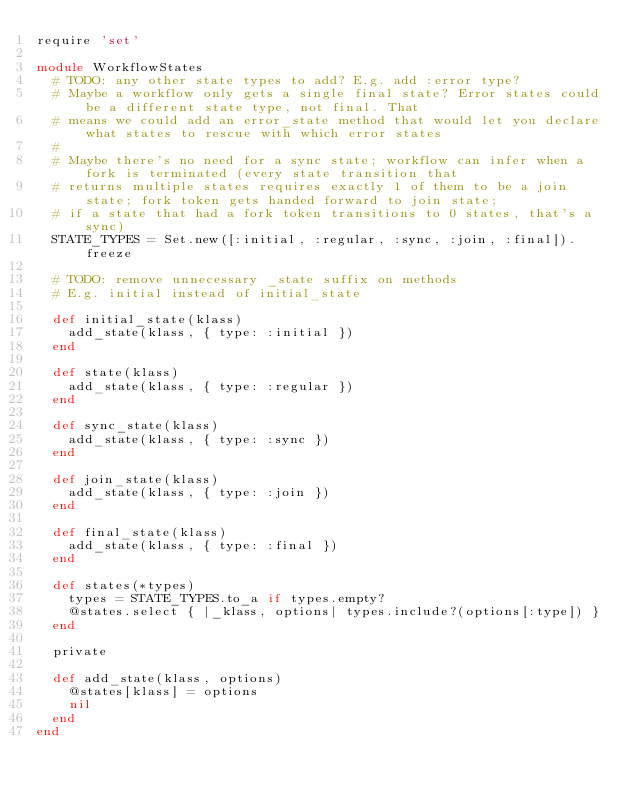Convert code to text. <code><loc_0><loc_0><loc_500><loc_500><_Ruby_>require 'set'

module WorkflowStates
  # TODO: any other state types to add? E.g. add :error type?
  # Maybe a workflow only gets a single final state? Error states could be a different state type, not final. That
  # means we could add an error_state method that would let you declare what states to rescue with which error states
  #
  # Maybe there's no need for a sync state; workflow can infer when a fork is terminated (every state transition that
  # returns multiple states requires exactly 1 of them to be a join state; fork token gets handed forward to join state;
  # if a state that had a fork token transitions to 0 states, that's a sync)
  STATE_TYPES = Set.new([:initial, :regular, :sync, :join, :final]).freeze

  # TODO: remove unnecessary _state suffix on methods
  # E.g. initial instead of initial_state

  def initial_state(klass)
    add_state(klass, { type: :initial })
  end

  def state(klass)
    add_state(klass, { type: :regular })
  end

  def sync_state(klass)
    add_state(klass, { type: :sync })
  end

  def join_state(klass)
    add_state(klass, { type: :join })
  end

  def final_state(klass)
    add_state(klass, { type: :final })
  end

  def states(*types)
    types = STATE_TYPES.to_a if types.empty?
    @states.select { |_klass, options| types.include?(options[:type]) }
  end

  private

  def add_state(klass, options)
    @states[klass] = options
    nil
  end
end</code> 